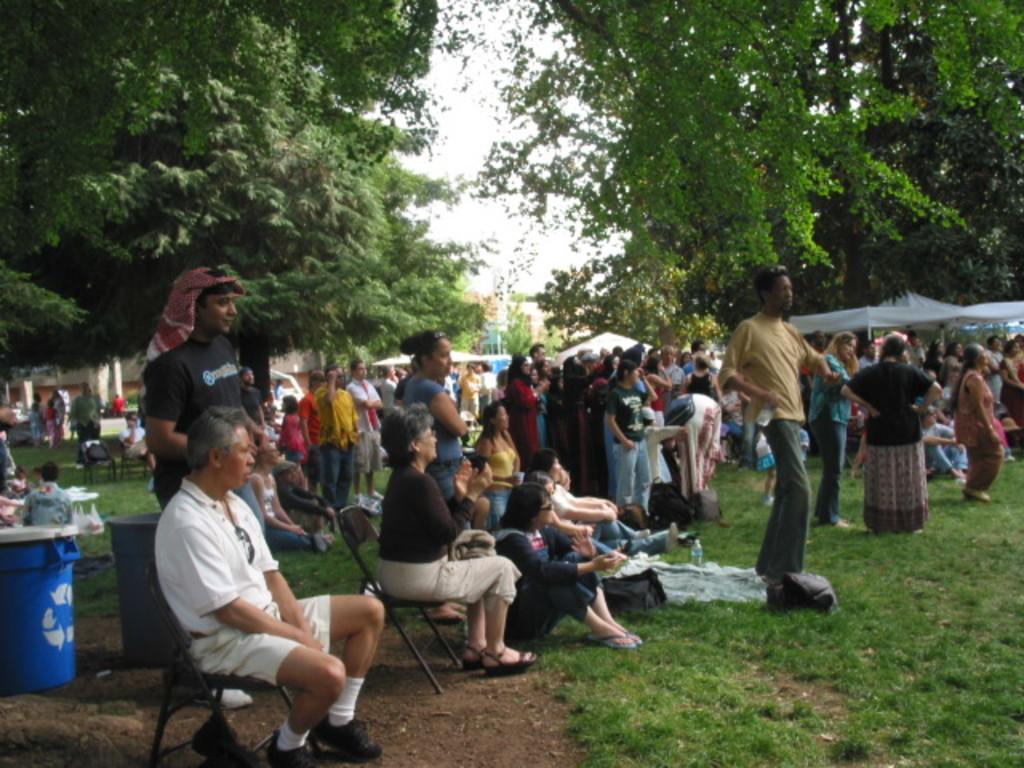How would you summarize this image in a sentence or two? In this image I can see the grass. I can see some people. On the left and right side, I can see the trees. At the top I can see the sky. 